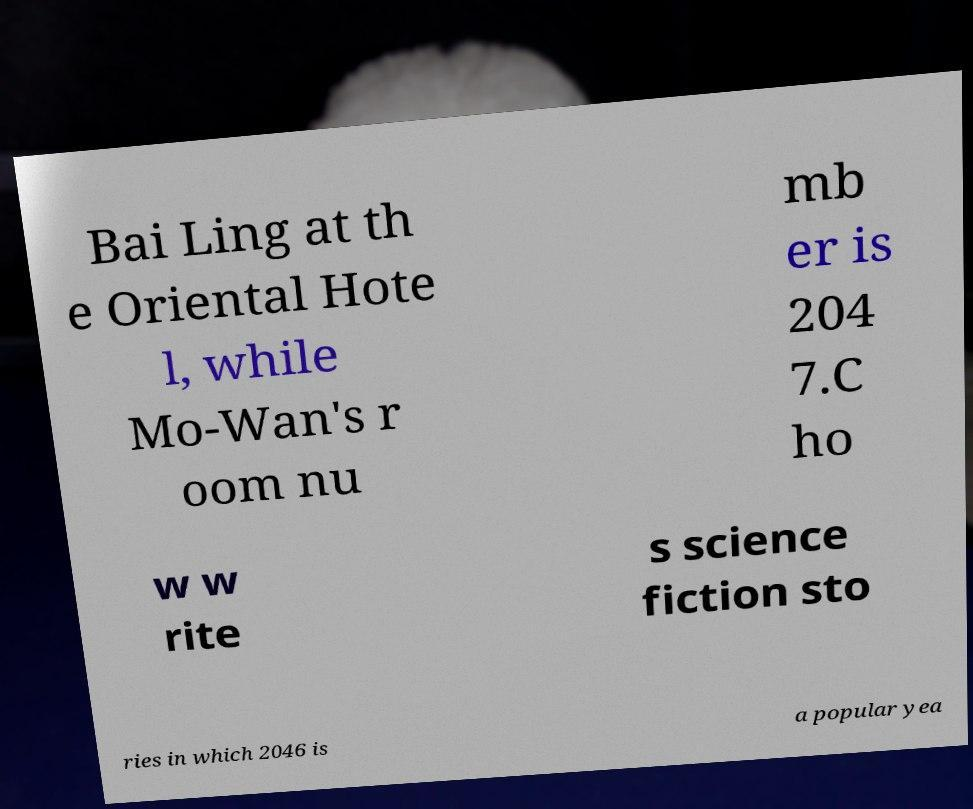What messages or text are displayed in this image? I need them in a readable, typed format. Bai Ling at th e Oriental Hote l, while Mo-Wan's r oom nu mb er is 204 7.C ho w w rite s science fiction sto ries in which 2046 is a popular yea 